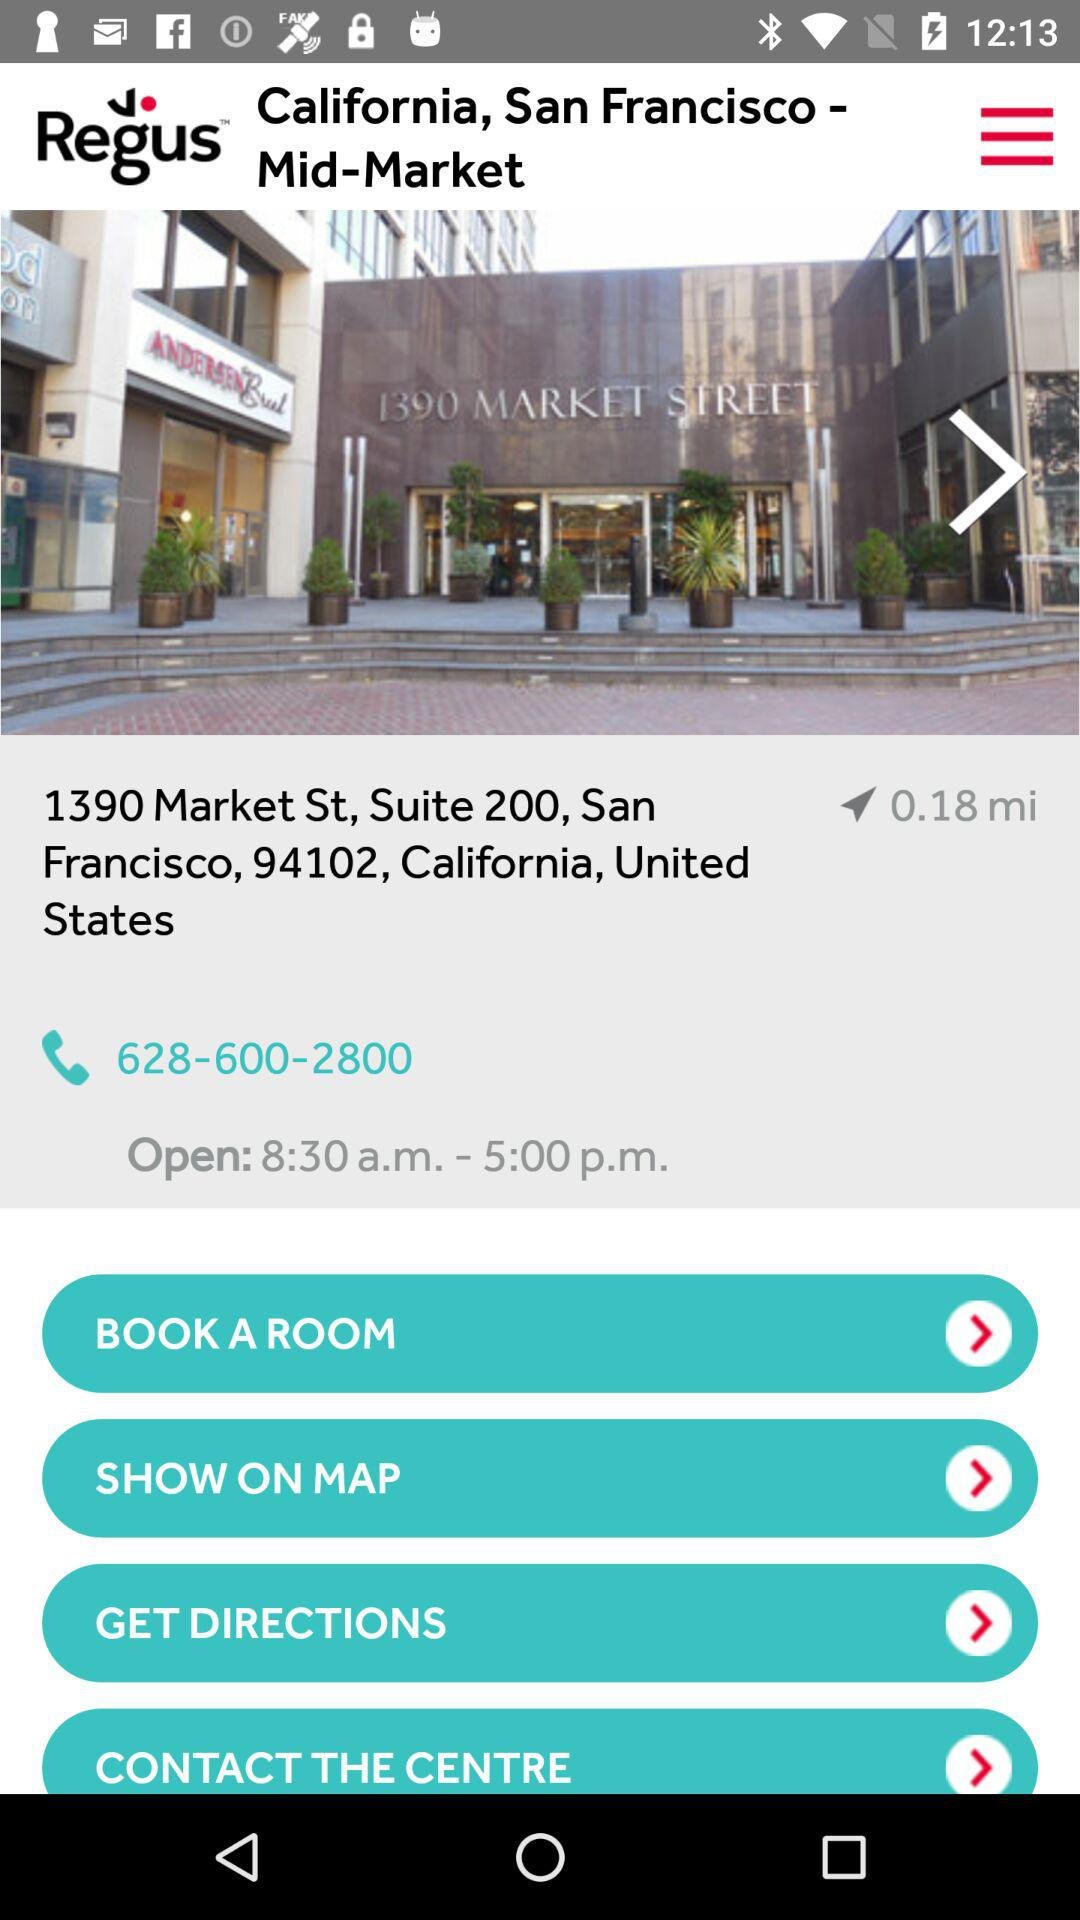What is the company name? The company name is "Regus PLC". 